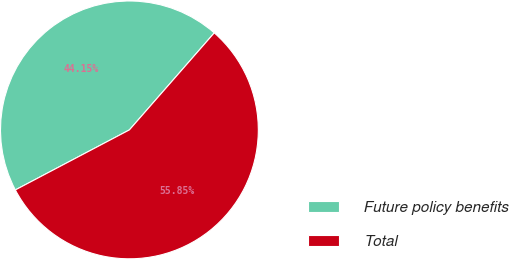Convert chart. <chart><loc_0><loc_0><loc_500><loc_500><pie_chart><fcel>Future policy benefits<fcel>Total<nl><fcel>44.15%<fcel>55.85%<nl></chart> 